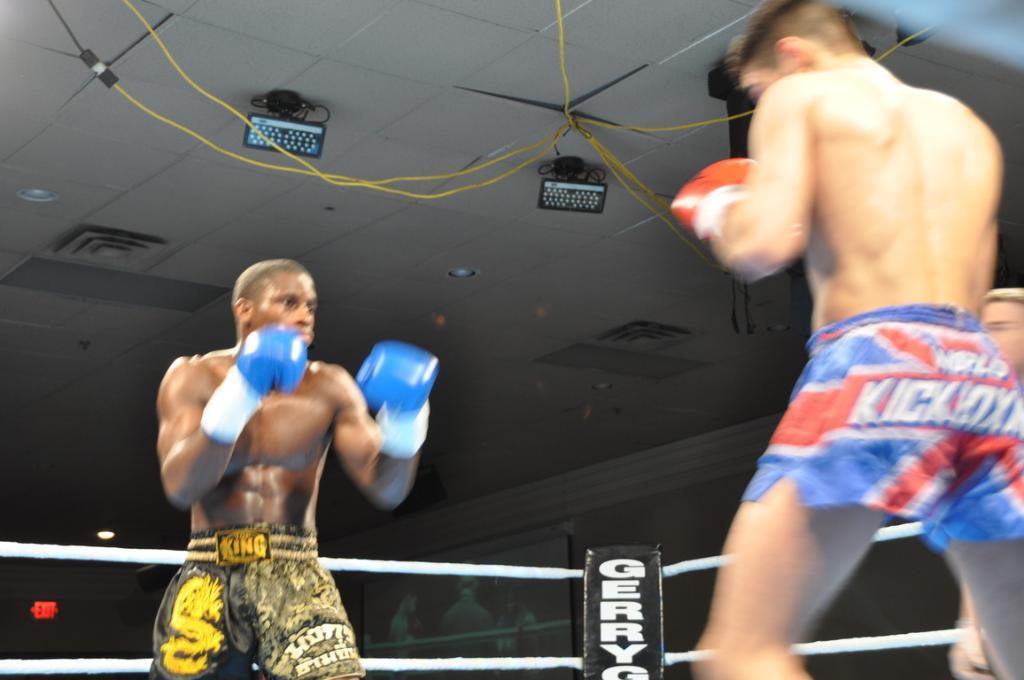Provide a one-sentence caption for the provided image. Two boxers are in a ring and one is wearing shorts that say, 'King'. 